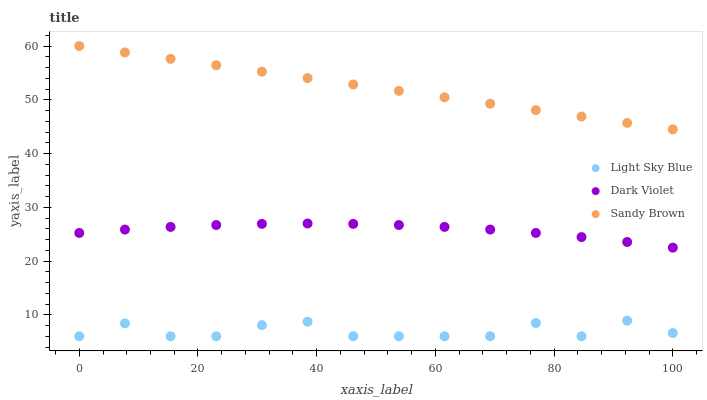Does Light Sky Blue have the minimum area under the curve?
Answer yes or no. Yes. Does Sandy Brown have the maximum area under the curve?
Answer yes or no. Yes. Does Dark Violet have the minimum area under the curve?
Answer yes or no. No. Does Dark Violet have the maximum area under the curve?
Answer yes or no. No. Is Sandy Brown the smoothest?
Answer yes or no. Yes. Is Light Sky Blue the roughest?
Answer yes or no. Yes. Is Dark Violet the smoothest?
Answer yes or no. No. Is Dark Violet the roughest?
Answer yes or no. No. Does Light Sky Blue have the lowest value?
Answer yes or no. Yes. Does Dark Violet have the lowest value?
Answer yes or no. No. Does Sandy Brown have the highest value?
Answer yes or no. Yes. Does Dark Violet have the highest value?
Answer yes or no. No. Is Dark Violet less than Sandy Brown?
Answer yes or no. Yes. Is Sandy Brown greater than Dark Violet?
Answer yes or no. Yes. Does Dark Violet intersect Sandy Brown?
Answer yes or no. No. 